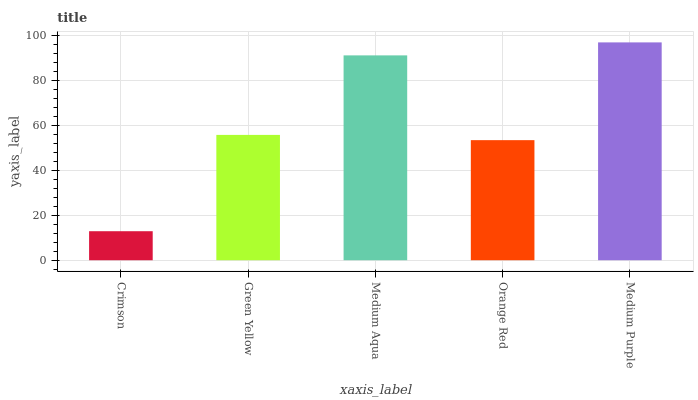Is Crimson the minimum?
Answer yes or no. Yes. Is Medium Purple the maximum?
Answer yes or no. Yes. Is Green Yellow the minimum?
Answer yes or no. No. Is Green Yellow the maximum?
Answer yes or no. No. Is Green Yellow greater than Crimson?
Answer yes or no. Yes. Is Crimson less than Green Yellow?
Answer yes or no. Yes. Is Crimson greater than Green Yellow?
Answer yes or no. No. Is Green Yellow less than Crimson?
Answer yes or no. No. Is Green Yellow the high median?
Answer yes or no. Yes. Is Green Yellow the low median?
Answer yes or no. Yes. Is Medium Purple the high median?
Answer yes or no. No. Is Medium Aqua the low median?
Answer yes or no. No. 